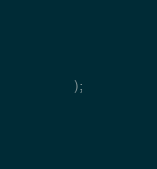Convert code to text. <code><loc_0><loc_0><loc_500><loc_500><_SQL_>);</code> 